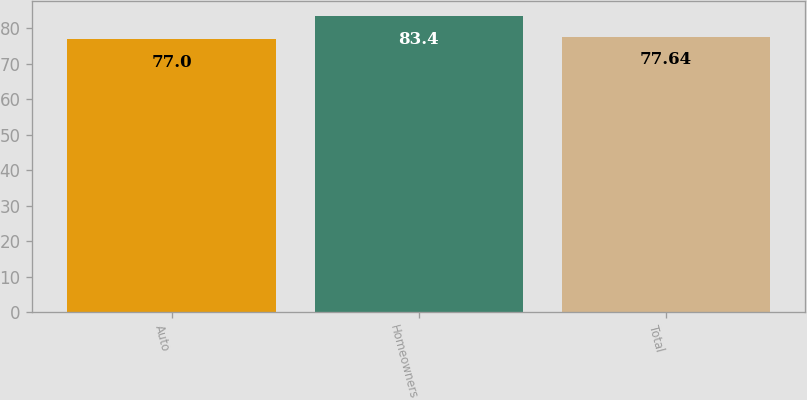Convert chart to OTSL. <chart><loc_0><loc_0><loc_500><loc_500><bar_chart><fcel>Auto<fcel>Homeowners<fcel>Total<nl><fcel>77<fcel>83.4<fcel>77.64<nl></chart> 